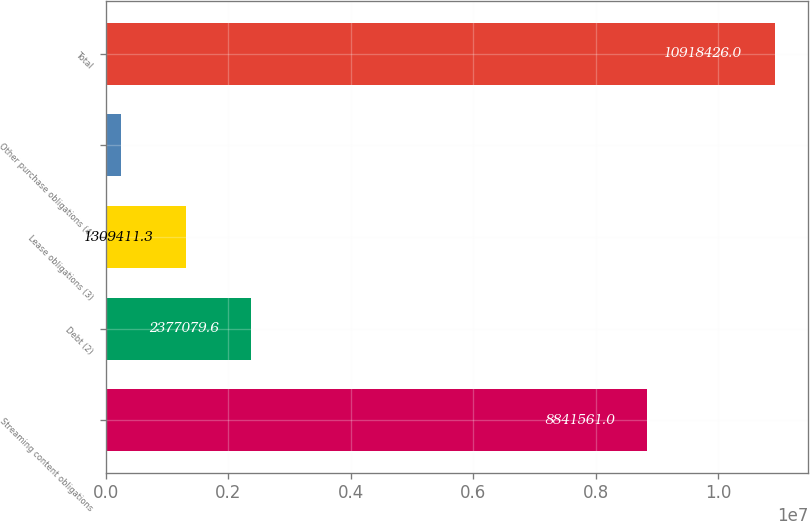Convert chart to OTSL. <chart><loc_0><loc_0><loc_500><loc_500><bar_chart><fcel>Streaming content obligations<fcel>Debt (2)<fcel>Lease obligations (3)<fcel>Other purchase obligations (4)<fcel>Total<nl><fcel>8.84156e+06<fcel>2.37708e+06<fcel>1.30941e+06<fcel>241743<fcel>1.09184e+07<nl></chart> 